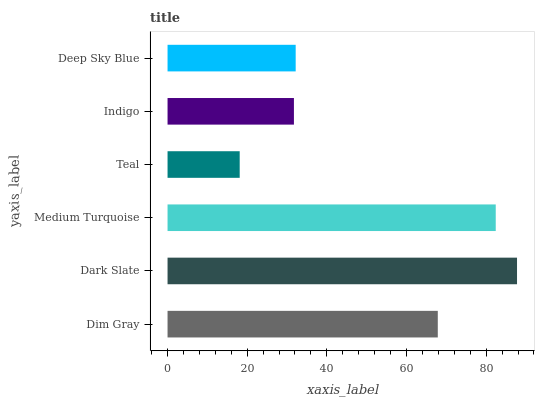Is Teal the minimum?
Answer yes or no. Yes. Is Dark Slate the maximum?
Answer yes or no. Yes. Is Medium Turquoise the minimum?
Answer yes or no. No. Is Medium Turquoise the maximum?
Answer yes or no. No. Is Dark Slate greater than Medium Turquoise?
Answer yes or no. Yes. Is Medium Turquoise less than Dark Slate?
Answer yes or no. Yes. Is Medium Turquoise greater than Dark Slate?
Answer yes or no. No. Is Dark Slate less than Medium Turquoise?
Answer yes or no. No. Is Dim Gray the high median?
Answer yes or no. Yes. Is Deep Sky Blue the low median?
Answer yes or no. Yes. Is Deep Sky Blue the high median?
Answer yes or no. No. Is Dark Slate the low median?
Answer yes or no. No. 